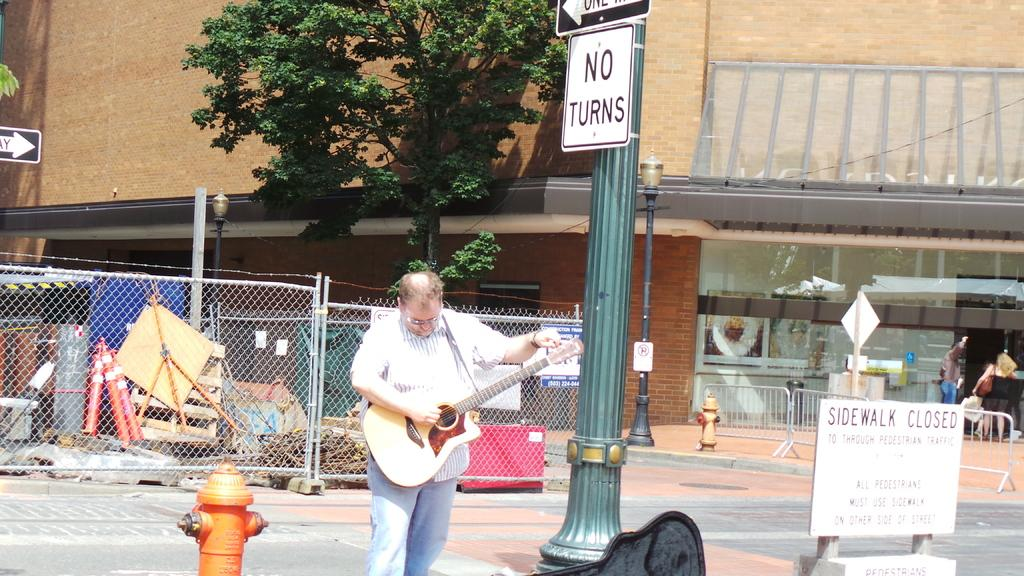What is the man in the image doing? The man is playing a guitar in the image. Where is the man located? The man is on a street in the image. What can be seen near the man? There is a pole with a sign board in the image. What does the sign board say? The sign board says "no turn." What is visible in the background of the image? There is a tree visible in the background of the image. How does the man express his disgust in the image? There is no indication of disgust in the image; the man is playing a guitar. What type of meeting is taking place in the image? There is no meeting present in the image; it features a man playing a guitar on a street. 